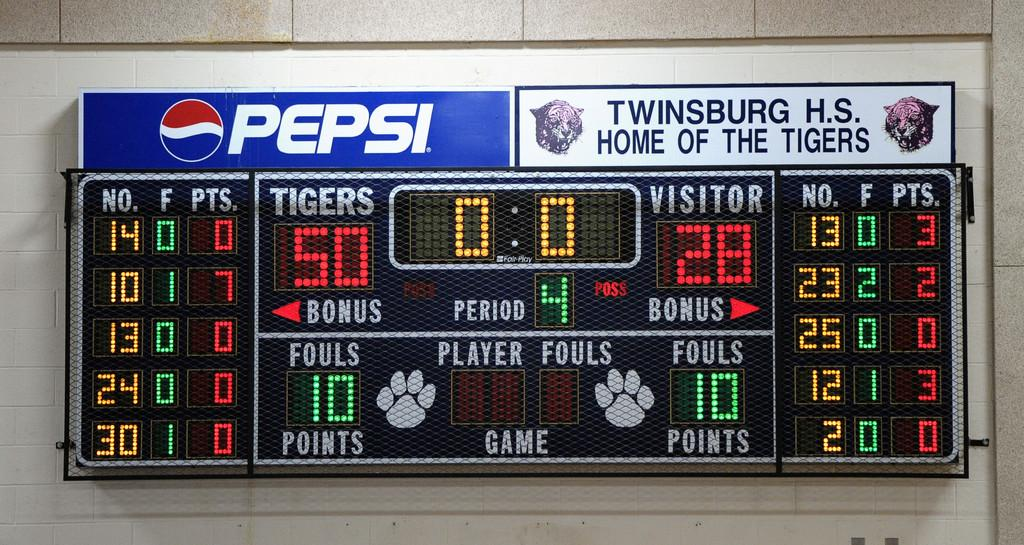<image>
Write a terse but informative summary of the picture. A scoreboard sponsored by Pepsi for the Twinsburg H.S. Tigers 